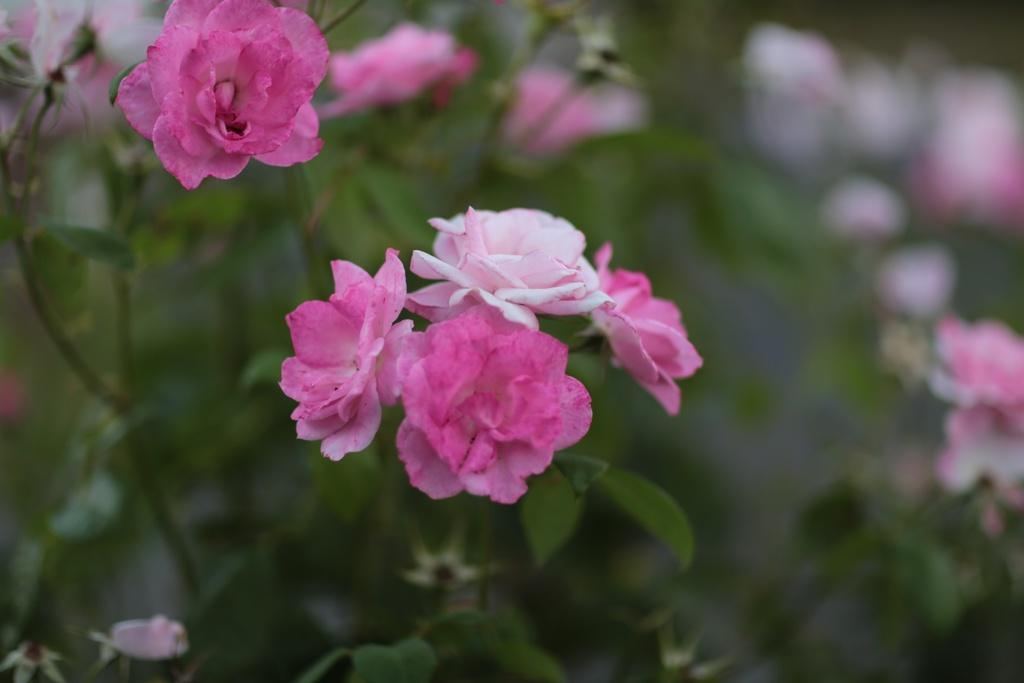What type of plants can be seen in the image? There are flowers and leaves in the image. What can be inferred about the focus of the image? The background of the image is blurry, suggesting that the flowers and leaves are the main focus. What type of cap is being worn by the umbrella in the image? There is no cap or umbrella present in the image; it features flowers and leaves with a blurry background. 